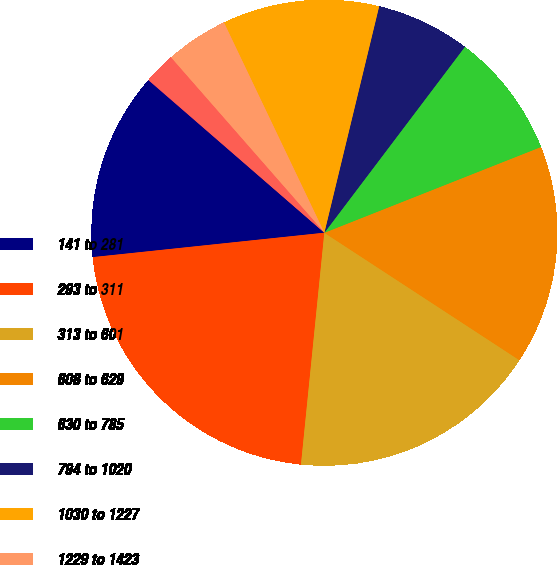Convert chart to OTSL. <chart><loc_0><loc_0><loc_500><loc_500><pie_chart><fcel>141 to 281<fcel>293 to 311<fcel>313 to 601<fcel>608 to 629<fcel>630 to 785<fcel>794 to 1020<fcel>1030 to 1227<fcel>1229 to 1423<fcel>1446 to 1446<fcel>1477 to 1477<nl><fcel>13.04%<fcel>21.73%<fcel>17.39%<fcel>15.21%<fcel>8.7%<fcel>6.52%<fcel>10.87%<fcel>4.35%<fcel>2.18%<fcel>0.01%<nl></chart> 